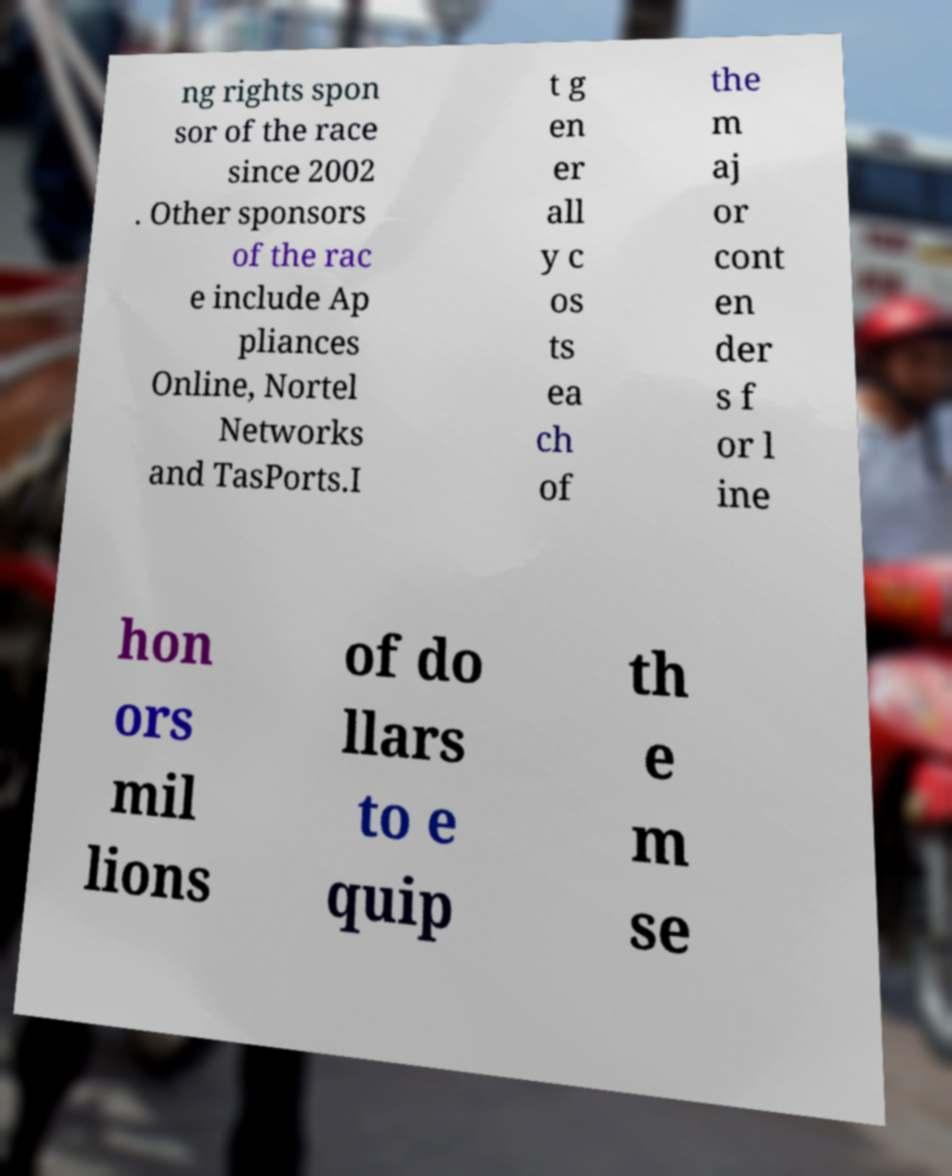There's text embedded in this image that I need extracted. Can you transcribe it verbatim? ng rights spon sor of the race since 2002 . Other sponsors of the rac e include Ap pliances Online, Nortel Networks and TasPorts.I t g en er all y c os ts ea ch of the m aj or cont en der s f or l ine hon ors mil lions of do llars to e quip th e m se 